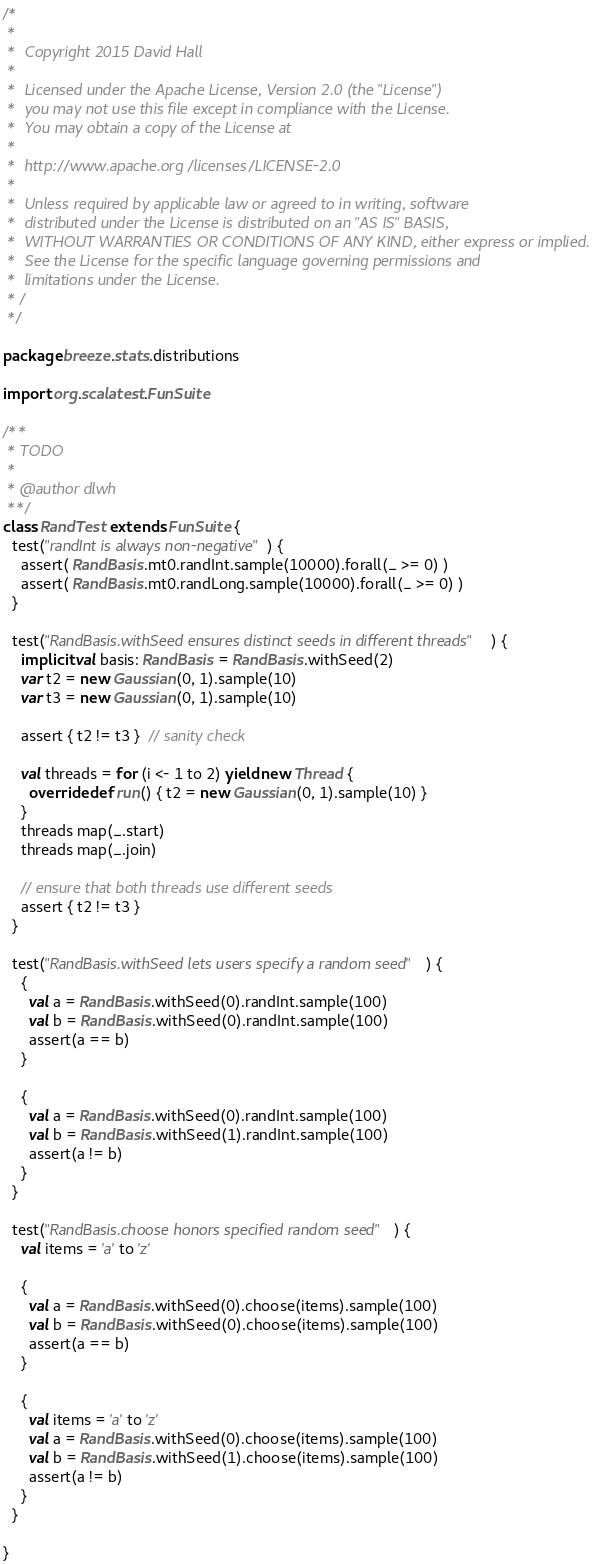Convert code to text. <code><loc_0><loc_0><loc_500><loc_500><_Scala_>/*
 *
 *  Copyright 2015 David Hall
 *
 *  Licensed under the Apache License, Version 2.0 (the "License")
 *  you may not use this file except in compliance with the License.
 *  You may obtain a copy of the License at
 *
 *  http://www.apache.org/licenses/LICENSE-2.0
 *
 *  Unless required by applicable law or agreed to in writing, software
 *  distributed under the License is distributed on an "AS IS" BASIS,
 *  WITHOUT WARRANTIES OR CONDITIONS OF ANY KIND, either express or implied.
 *  See the License for the specific language governing permissions and
 *  limitations under the License.
 * /
 */

package breeze.stats.distributions

import org.scalatest.FunSuite

/**
 * TODO
 *
 * @author dlwh
 **/
class RandTest extends FunSuite {
  test("randInt is always non-negative") {
    assert( RandBasis.mt0.randInt.sample(10000).forall(_ >= 0) )
    assert( RandBasis.mt0.randLong.sample(10000).forall(_ >= 0) )
  }

  test("RandBasis.withSeed ensures distinct seeds in different threads") {
    implicit val basis: RandBasis = RandBasis.withSeed(2)
    var t2 = new Gaussian(0, 1).sample(10)
    var t3 = new Gaussian(0, 1).sample(10)

    assert { t2 != t3 }  // sanity check

    val threads = for (i <- 1 to 2) yield new Thread {
      override def run() { t2 = new Gaussian(0, 1).sample(10) }
    }
    threads map(_.start)
    threads map(_.join)

    // ensure that both threads use different seeds
    assert { t2 != t3 }
  }

  test("RandBasis.withSeed lets users specify a random seed") {
    {
      val a = RandBasis.withSeed(0).randInt.sample(100)
      val b = RandBasis.withSeed(0).randInt.sample(100)
      assert(a == b)
    }

    {
      val a = RandBasis.withSeed(0).randInt.sample(100)
      val b = RandBasis.withSeed(1).randInt.sample(100)
      assert(a != b)
    }
  }

  test("RandBasis.choose honors specified random seed") {
    val items = 'a' to 'z'

    {
      val a = RandBasis.withSeed(0).choose(items).sample(100)
      val b = RandBasis.withSeed(0).choose(items).sample(100)
      assert(a == b)
    }

    {
      val items = 'a' to 'z'
      val a = RandBasis.withSeed(0).choose(items).sample(100)
      val b = RandBasis.withSeed(1).choose(items).sample(100)
      assert(a != b)
    }
  }

}
</code> 